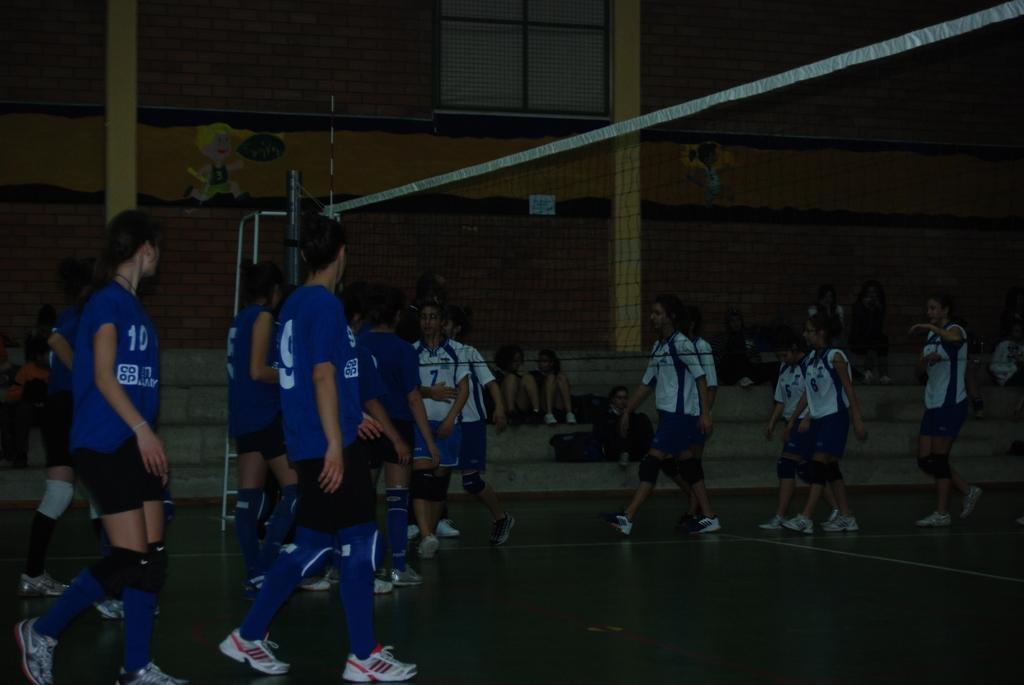Can you describe this image briefly? In this picture we can see a net, stand, window, bags, pillars, stickers on the wall and a group of people where some are sitting on steps and some are walking on the ground. 